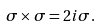Convert formula to latex. <formula><loc_0><loc_0><loc_500><loc_500>\sigma \times \sigma = 2 i \sigma .</formula> 